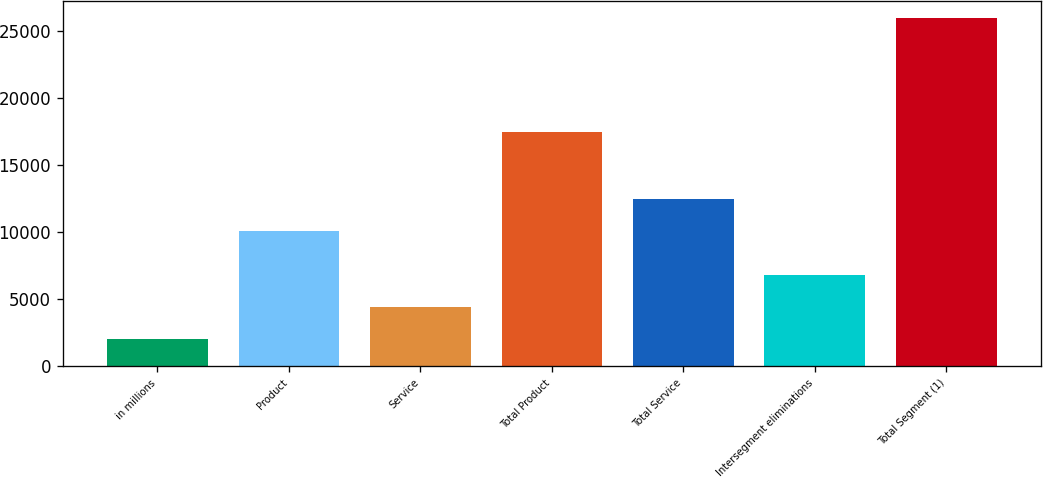Convert chart. <chart><loc_0><loc_0><loc_500><loc_500><bar_chart><fcel>in millions<fcel>Product<fcel>Service<fcel>Total Product<fcel>Total Service<fcel>Intersegment eliminations<fcel>Total Segment (1)<nl><fcel>2017<fcel>10064<fcel>4415.7<fcel>17467<fcel>12462.7<fcel>6814.4<fcel>26004<nl></chart> 